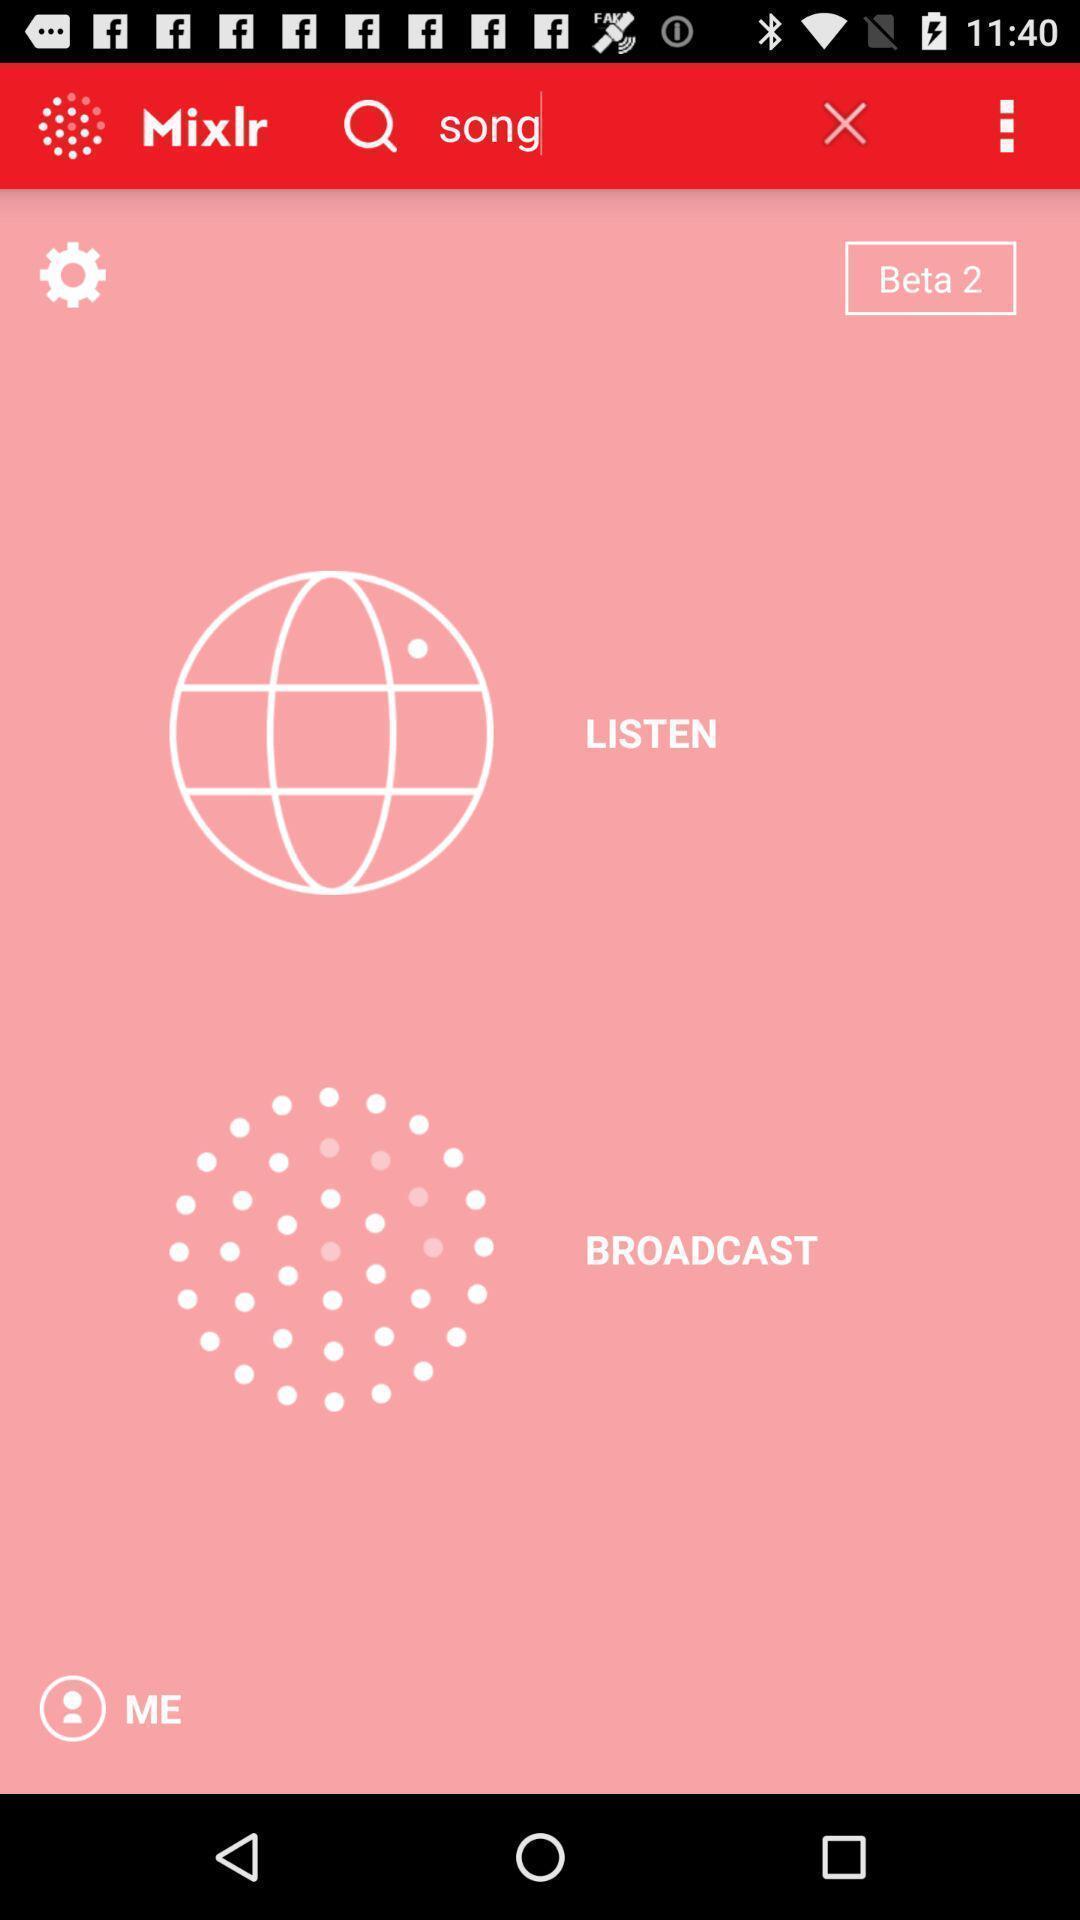Describe this image in words. Screen displaying to search songs. 